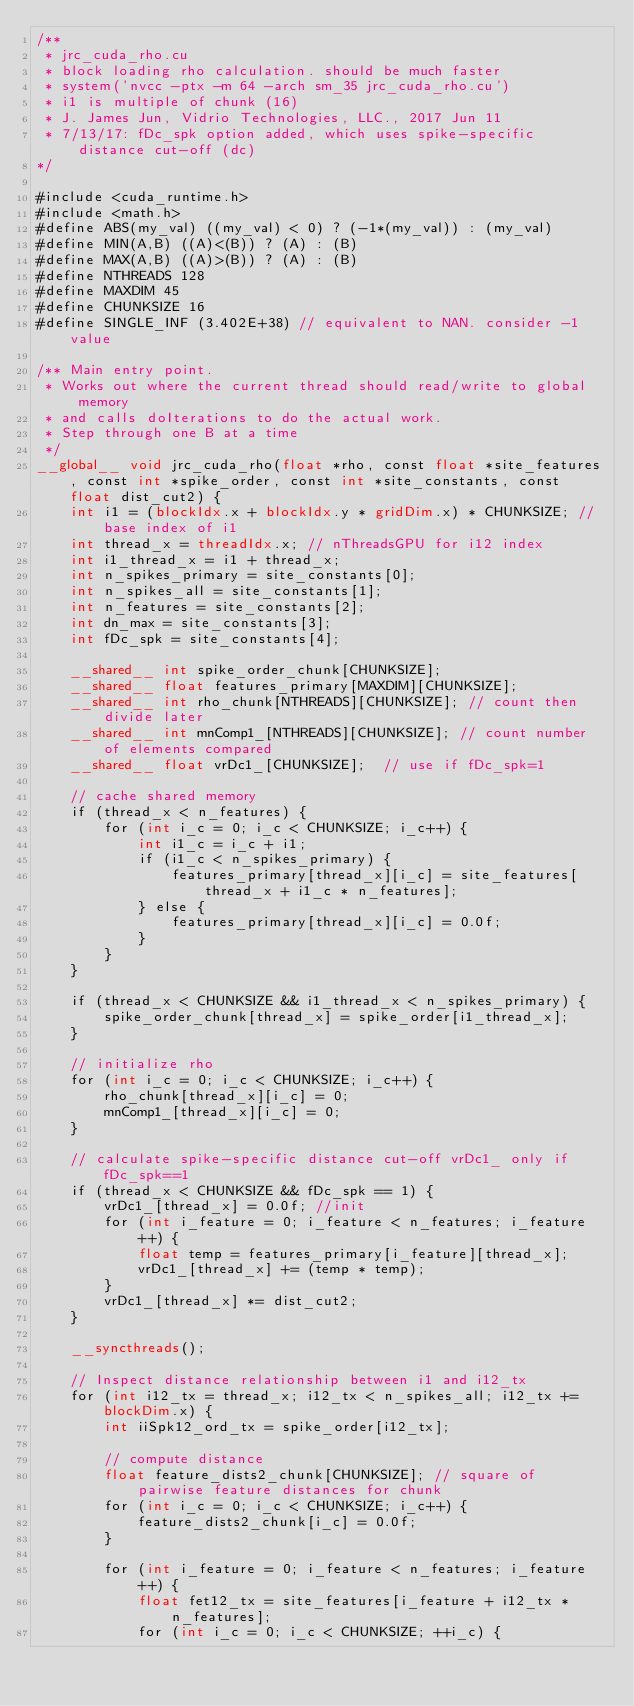<code> <loc_0><loc_0><loc_500><loc_500><_Cuda_>/**
 * jrc_cuda_rho.cu
 * block loading rho calculation. should be much faster
 * system('nvcc -ptx -m 64 -arch sm_35 jrc_cuda_rho.cu')
 * i1 is multiple of chunk (16)
 * J. James Jun, Vidrio Technologies, LLC., 2017 Jun 11
 * 7/13/17: fDc_spk option added, which uses spike-specific distance cut-off (dc)
*/

#include <cuda_runtime.h>
#include <math.h>
#define ABS(my_val) ((my_val) < 0) ? (-1*(my_val)) : (my_val)
#define MIN(A,B) ((A)<(B)) ? (A) : (B)
#define MAX(A,B) ((A)>(B)) ? (A) : (B)
#define NTHREADS 128
#define MAXDIM 45
#define CHUNKSIZE 16
#define SINGLE_INF (3.402E+38) // equivalent to NAN. consider -1 value

/** Main entry point.
 * Works out where the current thread should read/write to global memory
 * and calls doIterations to do the actual work.
 * Step through one B at a time
 */
__global__ void jrc_cuda_rho(float *rho, const float *site_features, const int *spike_order, const int *site_constants, const float dist_cut2) {
    int i1 = (blockIdx.x + blockIdx.y * gridDim.x) * CHUNKSIZE; // base index of i1
    int thread_x = threadIdx.x; // nThreadsGPU for i12 index
    int i1_thread_x = i1 + thread_x;
    int n_spikes_primary = site_constants[0];
    int n_spikes_all = site_constants[1];
    int n_features = site_constants[2];
    int dn_max = site_constants[3];
    int fDc_spk = site_constants[4];

    __shared__ int spike_order_chunk[CHUNKSIZE];
    __shared__ float features_primary[MAXDIM][CHUNKSIZE];
    __shared__ int rho_chunk[NTHREADS][CHUNKSIZE]; // count then divide later
    __shared__ int mnComp1_[NTHREADS][CHUNKSIZE]; // count number of elements compared
    __shared__ float vrDc1_[CHUNKSIZE];  // use if fDc_spk=1

    // cache shared memory
    if (thread_x < n_features) {
        for (int i_c = 0; i_c < CHUNKSIZE; i_c++) {
            int i1_c = i_c + i1;
            if (i1_c < n_spikes_primary) {
                features_primary[thread_x][i_c] = site_features[thread_x + i1_c * n_features];
            } else {
                features_primary[thread_x][i_c] = 0.0f;
            }
        }
    }

    if (thread_x < CHUNKSIZE && i1_thread_x < n_spikes_primary) {
        spike_order_chunk[thread_x] = spike_order[i1_thread_x];
    }

    // initialize rho
    for (int i_c = 0; i_c < CHUNKSIZE; i_c++) {
        rho_chunk[thread_x][i_c] = 0;
        mnComp1_[thread_x][i_c] = 0;
    }

    // calculate spike-specific distance cut-off vrDc1_ only if fDc_spk==1
    if (thread_x < CHUNKSIZE && fDc_spk == 1) {
        vrDc1_[thread_x] = 0.0f; //init
        for (int i_feature = 0; i_feature < n_features; i_feature++) {
            float temp = features_primary[i_feature][thread_x];
            vrDc1_[thread_x] += (temp * temp);
        }
        vrDc1_[thread_x] *= dist_cut2;
    }

    __syncthreads();

    // Inspect distance relationship between i1 and i12_tx
    for (int i12_tx = thread_x; i12_tx < n_spikes_all; i12_tx += blockDim.x) {
        int iiSpk12_ord_tx = spike_order[i12_tx];

        // compute distance
        float feature_dists2_chunk[CHUNKSIZE]; // square of pairwise feature distances for chunk
        for (int i_c = 0; i_c < CHUNKSIZE; i_c++) {
            feature_dists2_chunk[i_c] = 0.0f;
        }

        for (int i_feature = 0; i_feature < n_features; i_feature++) {
            float fet12_tx = site_features[i_feature + i12_tx * n_features];
            for (int i_c = 0; i_c < CHUNKSIZE; ++i_c) {</code> 